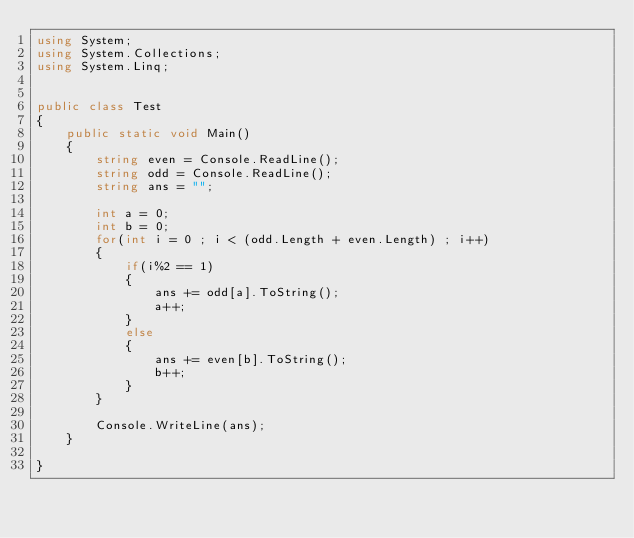Convert code to text. <code><loc_0><loc_0><loc_500><loc_500><_C#_>using System;
using System.Collections;
using System.Linq;


public class Test
{	
	public static void Main()
	{
		string even = Console.ReadLine();
        string odd = Console.ReadLine();
        string ans = "";

        int a = 0;
        int b = 0;
        for(int i = 0 ; i < (odd.Length + even.Length) ; i++)
        {
            if(i%2 == 1)
            {
                ans += odd[a].ToString();
                a++;
            }
            else
            {
                ans += even[b].ToString();
                b++;
            }
        }

        Console.WriteLine(ans);
	}

}</code> 